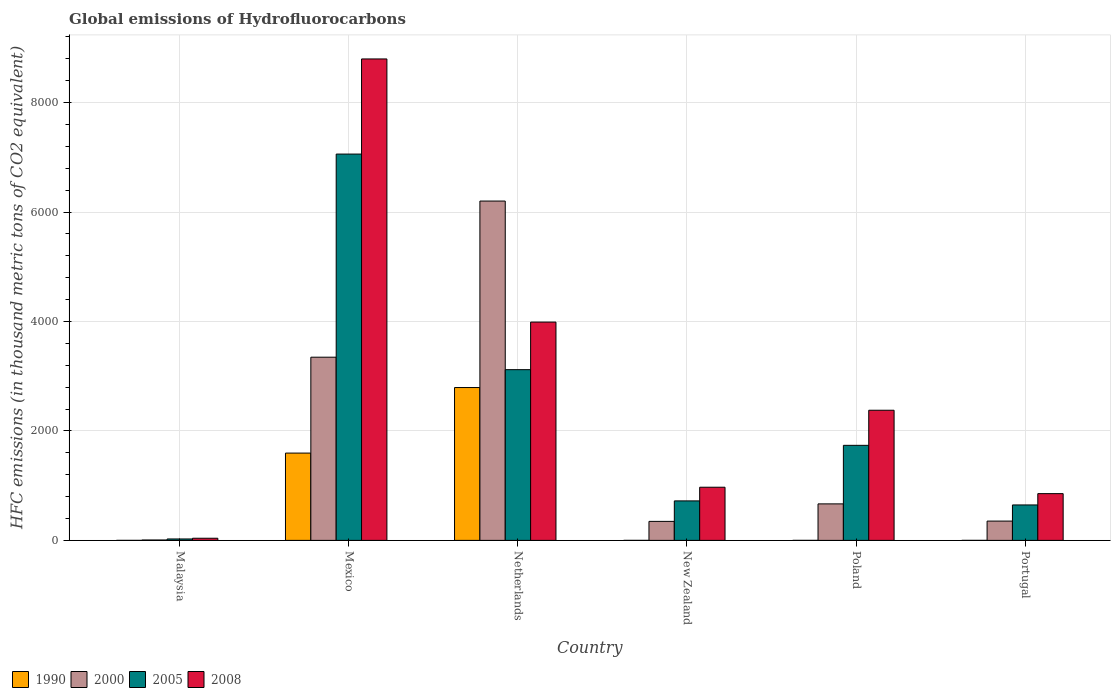Are the number of bars on each tick of the X-axis equal?
Give a very brief answer. Yes. How many bars are there on the 2nd tick from the left?
Make the answer very short. 4. What is the label of the 1st group of bars from the left?
Keep it short and to the point. Malaysia. What is the global emissions of Hydrofluorocarbons in 2008 in Mexico?
Your response must be concise. 8796.9. Across all countries, what is the maximum global emissions of Hydrofluorocarbons in 2008?
Your answer should be compact. 8796.9. Across all countries, what is the minimum global emissions of Hydrofluorocarbons in 2005?
Provide a short and direct response. 26.1. In which country was the global emissions of Hydrofluorocarbons in 1990 maximum?
Make the answer very short. Netherlands. In which country was the global emissions of Hydrofluorocarbons in 2000 minimum?
Provide a short and direct response. Malaysia. What is the total global emissions of Hydrofluorocarbons in 1990 in the graph?
Provide a short and direct response. 4388.8. What is the difference between the global emissions of Hydrofluorocarbons in 2000 in Malaysia and that in Mexico?
Offer a terse response. -3340.4. What is the difference between the global emissions of Hydrofluorocarbons in 2005 in New Zealand and the global emissions of Hydrofluorocarbons in 2008 in Malaysia?
Provide a succinct answer. 682.5. What is the average global emissions of Hydrofluorocarbons in 2000 per country?
Make the answer very short. 1820.3. What is the difference between the global emissions of Hydrofluorocarbons of/in 2008 and global emissions of Hydrofluorocarbons of/in 2000 in Mexico?
Ensure brevity in your answer.  5449.6. In how many countries, is the global emissions of Hydrofluorocarbons in 2005 greater than 400 thousand metric tons?
Your response must be concise. 5. What is the ratio of the global emissions of Hydrofluorocarbons in 2000 in Mexico to that in New Zealand?
Your answer should be compact. 9.64. What is the difference between the highest and the second highest global emissions of Hydrofluorocarbons in 2000?
Offer a terse response. 2853.1. What is the difference between the highest and the lowest global emissions of Hydrofluorocarbons in 1990?
Your answer should be very brief. 2792.8. In how many countries, is the global emissions of Hydrofluorocarbons in 2005 greater than the average global emissions of Hydrofluorocarbons in 2005 taken over all countries?
Your answer should be compact. 2. Is the sum of the global emissions of Hydrofluorocarbons in 1990 in New Zealand and Poland greater than the maximum global emissions of Hydrofluorocarbons in 2005 across all countries?
Provide a short and direct response. No. Is it the case that in every country, the sum of the global emissions of Hydrofluorocarbons in 2008 and global emissions of Hydrofluorocarbons in 2000 is greater than the sum of global emissions of Hydrofluorocarbons in 1990 and global emissions of Hydrofluorocarbons in 2005?
Your answer should be very brief. No. What does the 2nd bar from the left in New Zealand represents?
Your response must be concise. 2000. What does the 4th bar from the right in Malaysia represents?
Offer a terse response. 1990. How many bars are there?
Provide a succinct answer. 24. Are all the bars in the graph horizontal?
Give a very brief answer. No. How many countries are there in the graph?
Offer a terse response. 6. Are the values on the major ticks of Y-axis written in scientific E-notation?
Ensure brevity in your answer.  No. Where does the legend appear in the graph?
Ensure brevity in your answer.  Bottom left. What is the title of the graph?
Offer a terse response. Global emissions of Hydrofluorocarbons. Does "1968" appear as one of the legend labels in the graph?
Provide a short and direct response. No. What is the label or title of the Y-axis?
Make the answer very short. HFC emissions (in thousand metric tons of CO2 equivalent). What is the HFC emissions (in thousand metric tons of CO2 equivalent) in 2000 in Malaysia?
Offer a very short reply. 6.9. What is the HFC emissions (in thousand metric tons of CO2 equivalent) of 2005 in Malaysia?
Your response must be concise. 26.1. What is the HFC emissions (in thousand metric tons of CO2 equivalent) in 2008 in Malaysia?
Provide a short and direct response. 39.2. What is the HFC emissions (in thousand metric tons of CO2 equivalent) in 1990 in Mexico?
Your answer should be very brief. 1595.3. What is the HFC emissions (in thousand metric tons of CO2 equivalent) of 2000 in Mexico?
Your answer should be compact. 3347.3. What is the HFC emissions (in thousand metric tons of CO2 equivalent) of 2005 in Mexico?
Give a very brief answer. 7058.9. What is the HFC emissions (in thousand metric tons of CO2 equivalent) of 2008 in Mexico?
Your answer should be very brief. 8796.9. What is the HFC emissions (in thousand metric tons of CO2 equivalent) of 1990 in Netherlands?
Give a very brief answer. 2792.9. What is the HFC emissions (in thousand metric tons of CO2 equivalent) of 2000 in Netherlands?
Make the answer very short. 6200.4. What is the HFC emissions (in thousand metric tons of CO2 equivalent) in 2005 in Netherlands?
Offer a very short reply. 3119.5. What is the HFC emissions (in thousand metric tons of CO2 equivalent) in 2008 in Netherlands?
Your answer should be compact. 3988.8. What is the HFC emissions (in thousand metric tons of CO2 equivalent) of 2000 in New Zealand?
Keep it short and to the point. 347.3. What is the HFC emissions (in thousand metric tons of CO2 equivalent) in 2005 in New Zealand?
Offer a very short reply. 721.7. What is the HFC emissions (in thousand metric tons of CO2 equivalent) in 2008 in New Zealand?
Your response must be concise. 971.4. What is the HFC emissions (in thousand metric tons of CO2 equivalent) in 1990 in Poland?
Offer a terse response. 0.1. What is the HFC emissions (in thousand metric tons of CO2 equivalent) of 2000 in Poland?
Offer a terse response. 667.2. What is the HFC emissions (in thousand metric tons of CO2 equivalent) in 2005 in Poland?
Ensure brevity in your answer.  1736.7. What is the HFC emissions (in thousand metric tons of CO2 equivalent) in 2008 in Poland?
Ensure brevity in your answer.  2378. What is the HFC emissions (in thousand metric tons of CO2 equivalent) in 2000 in Portugal?
Provide a short and direct response. 352.7. What is the HFC emissions (in thousand metric tons of CO2 equivalent) in 2005 in Portugal?
Give a very brief answer. 647.7. What is the HFC emissions (in thousand metric tons of CO2 equivalent) of 2008 in Portugal?
Make the answer very short. 854.4. Across all countries, what is the maximum HFC emissions (in thousand metric tons of CO2 equivalent) of 1990?
Provide a succinct answer. 2792.9. Across all countries, what is the maximum HFC emissions (in thousand metric tons of CO2 equivalent) of 2000?
Your answer should be compact. 6200.4. Across all countries, what is the maximum HFC emissions (in thousand metric tons of CO2 equivalent) of 2005?
Your answer should be compact. 7058.9. Across all countries, what is the maximum HFC emissions (in thousand metric tons of CO2 equivalent) in 2008?
Your answer should be compact. 8796.9. Across all countries, what is the minimum HFC emissions (in thousand metric tons of CO2 equivalent) of 1990?
Give a very brief answer. 0.1. Across all countries, what is the minimum HFC emissions (in thousand metric tons of CO2 equivalent) of 2005?
Your response must be concise. 26.1. Across all countries, what is the minimum HFC emissions (in thousand metric tons of CO2 equivalent) in 2008?
Your response must be concise. 39.2. What is the total HFC emissions (in thousand metric tons of CO2 equivalent) in 1990 in the graph?
Ensure brevity in your answer.  4388.8. What is the total HFC emissions (in thousand metric tons of CO2 equivalent) of 2000 in the graph?
Your answer should be very brief. 1.09e+04. What is the total HFC emissions (in thousand metric tons of CO2 equivalent) in 2005 in the graph?
Offer a terse response. 1.33e+04. What is the total HFC emissions (in thousand metric tons of CO2 equivalent) in 2008 in the graph?
Keep it short and to the point. 1.70e+04. What is the difference between the HFC emissions (in thousand metric tons of CO2 equivalent) in 1990 in Malaysia and that in Mexico?
Your response must be concise. -1595.2. What is the difference between the HFC emissions (in thousand metric tons of CO2 equivalent) in 2000 in Malaysia and that in Mexico?
Provide a succinct answer. -3340.4. What is the difference between the HFC emissions (in thousand metric tons of CO2 equivalent) in 2005 in Malaysia and that in Mexico?
Make the answer very short. -7032.8. What is the difference between the HFC emissions (in thousand metric tons of CO2 equivalent) in 2008 in Malaysia and that in Mexico?
Make the answer very short. -8757.7. What is the difference between the HFC emissions (in thousand metric tons of CO2 equivalent) of 1990 in Malaysia and that in Netherlands?
Provide a succinct answer. -2792.8. What is the difference between the HFC emissions (in thousand metric tons of CO2 equivalent) of 2000 in Malaysia and that in Netherlands?
Provide a short and direct response. -6193.5. What is the difference between the HFC emissions (in thousand metric tons of CO2 equivalent) of 2005 in Malaysia and that in Netherlands?
Give a very brief answer. -3093.4. What is the difference between the HFC emissions (in thousand metric tons of CO2 equivalent) of 2008 in Malaysia and that in Netherlands?
Give a very brief answer. -3949.6. What is the difference between the HFC emissions (in thousand metric tons of CO2 equivalent) of 2000 in Malaysia and that in New Zealand?
Ensure brevity in your answer.  -340.4. What is the difference between the HFC emissions (in thousand metric tons of CO2 equivalent) in 2005 in Malaysia and that in New Zealand?
Ensure brevity in your answer.  -695.6. What is the difference between the HFC emissions (in thousand metric tons of CO2 equivalent) in 2008 in Malaysia and that in New Zealand?
Provide a short and direct response. -932.2. What is the difference between the HFC emissions (in thousand metric tons of CO2 equivalent) of 1990 in Malaysia and that in Poland?
Provide a succinct answer. 0. What is the difference between the HFC emissions (in thousand metric tons of CO2 equivalent) of 2000 in Malaysia and that in Poland?
Make the answer very short. -660.3. What is the difference between the HFC emissions (in thousand metric tons of CO2 equivalent) of 2005 in Malaysia and that in Poland?
Ensure brevity in your answer.  -1710.6. What is the difference between the HFC emissions (in thousand metric tons of CO2 equivalent) in 2008 in Malaysia and that in Poland?
Make the answer very short. -2338.8. What is the difference between the HFC emissions (in thousand metric tons of CO2 equivalent) of 1990 in Malaysia and that in Portugal?
Keep it short and to the point. -0.1. What is the difference between the HFC emissions (in thousand metric tons of CO2 equivalent) of 2000 in Malaysia and that in Portugal?
Offer a terse response. -345.8. What is the difference between the HFC emissions (in thousand metric tons of CO2 equivalent) in 2005 in Malaysia and that in Portugal?
Make the answer very short. -621.6. What is the difference between the HFC emissions (in thousand metric tons of CO2 equivalent) of 2008 in Malaysia and that in Portugal?
Give a very brief answer. -815.2. What is the difference between the HFC emissions (in thousand metric tons of CO2 equivalent) of 1990 in Mexico and that in Netherlands?
Provide a succinct answer. -1197.6. What is the difference between the HFC emissions (in thousand metric tons of CO2 equivalent) of 2000 in Mexico and that in Netherlands?
Provide a succinct answer. -2853.1. What is the difference between the HFC emissions (in thousand metric tons of CO2 equivalent) in 2005 in Mexico and that in Netherlands?
Provide a short and direct response. 3939.4. What is the difference between the HFC emissions (in thousand metric tons of CO2 equivalent) in 2008 in Mexico and that in Netherlands?
Make the answer very short. 4808.1. What is the difference between the HFC emissions (in thousand metric tons of CO2 equivalent) of 1990 in Mexico and that in New Zealand?
Your response must be concise. 1595.1. What is the difference between the HFC emissions (in thousand metric tons of CO2 equivalent) of 2000 in Mexico and that in New Zealand?
Keep it short and to the point. 3000. What is the difference between the HFC emissions (in thousand metric tons of CO2 equivalent) in 2005 in Mexico and that in New Zealand?
Provide a short and direct response. 6337.2. What is the difference between the HFC emissions (in thousand metric tons of CO2 equivalent) in 2008 in Mexico and that in New Zealand?
Provide a short and direct response. 7825.5. What is the difference between the HFC emissions (in thousand metric tons of CO2 equivalent) of 1990 in Mexico and that in Poland?
Offer a terse response. 1595.2. What is the difference between the HFC emissions (in thousand metric tons of CO2 equivalent) of 2000 in Mexico and that in Poland?
Ensure brevity in your answer.  2680.1. What is the difference between the HFC emissions (in thousand metric tons of CO2 equivalent) in 2005 in Mexico and that in Poland?
Your response must be concise. 5322.2. What is the difference between the HFC emissions (in thousand metric tons of CO2 equivalent) in 2008 in Mexico and that in Poland?
Your answer should be compact. 6418.9. What is the difference between the HFC emissions (in thousand metric tons of CO2 equivalent) of 1990 in Mexico and that in Portugal?
Provide a succinct answer. 1595.1. What is the difference between the HFC emissions (in thousand metric tons of CO2 equivalent) in 2000 in Mexico and that in Portugal?
Offer a very short reply. 2994.6. What is the difference between the HFC emissions (in thousand metric tons of CO2 equivalent) in 2005 in Mexico and that in Portugal?
Make the answer very short. 6411.2. What is the difference between the HFC emissions (in thousand metric tons of CO2 equivalent) of 2008 in Mexico and that in Portugal?
Give a very brief answer. 7942.5. What is the difference between the HFC emissions (in thousand metric tons of CO2 equivalent) of 1990 in Netherlands and that in New Zealand?
Your answer should be very brief. 2792.7. What is the difference between the HFC emissions (in thousand metric tons of CO2 equivalent) in 2000 in Netherlands and that in New Zealand?
Offer a very short reply. 5853.1. What is the difference between the HFC emissions (in thousand metric tons of CO2 equivalent) in 2005 in Netherlands and that in New Zealand?
Ensure brevity in your answer.  2397.8. What is the difference between the HFC emissions (in thousand metric tons of CO2 equivalent) in 2008 in Netherlands and that in New Zealand?
Give a very brief answer. 3017.4. What is the difference between the HFC emissions (in thousand metric tons of CO2 equivalent) of 1990 in Netherlands and that in Poland?
Your answer should be very brief. 2792.8. What is the difference between the HFC emissions (in thousand metric tons of CO2 equivalent) of 2000 in Netherlands and that in Poland?
Give a very brief answer. 5533.2. What is the difference between the HFC emissions (in thousand metric tons of CO2 equivalent) of 2005 in Netherlands and that in Poland?
Make the answer very short. 1382.8. What is the difference between the HFC emissions (in thousand metric tons of CO2 equivalent) in 2008 in Netherlands and that in Poland?
Your response must be concise. 1610.8. What is the difference between the HFC emissions (in thousand metric tons of CO2 equivalent) of 1990 in Netherlands and that in Portugal?
Your answer should be compact. 2792.7. What is the difference between the HFC emissions (in thousand metric tons of CO2 equivalent) of 2000 in Netherlands and that in Portugal?
Offer a very short reply. 5847.7. What is the difference between the HFC emissions (in thousand metric tons of CO2 equivalent) of 2005 in Netherlands and that in Portugal?
Offer a very short reply. 2471.8. What is the difference between the HFC emissions (in thousand metric tons of CO2 equivalent) of 2008 in Netherlands and that in Portugal?
Keep it short and to the point. 3134.4. What is the difference between the HFC emissions (in thousand metric tons of CO2 equivalent) of 2000 in New Zealand and that in Poland?
Offer a terse response. -319.9. What is the difference between the HFC emissions (in thousand metric tons of CO2 equivalent) of 2005 in New Zealand and that in Poland?
Offer a very short reply. -1015. What is the difference between the HFC emissions (in thousand metric tons of CO2 equivalent) in 2008 in New Zealand and that in Poland?
Offer a very short reply. -1406.6. What is the difference between the HFC emissions (in thousand metric tons of CO2 equivalent) of 1990 in New Zealand and that in Portugal?
Your answer should be very brief. 0. What is the difference between the HFC emissions (in thousand metric tons of CO2 equivalent) in 2008 in New Zealand and that in Portugal?
Your response must be concise. 117. What is the difference between the HFC emissions (in thousand metric tons of CO2 equivalent) of 1990 in Poland and that in Portugal?
Provide a short and direct response. -0.1. What is the difference between the HFC emissions (in thousand metric tons of CO2 equivalent) in 2000 in Poland and that in Portugal?
Offer a terse response. 314.5. What is the difference between the HFC emissions (in thousand metric tons of CO2 equivalent) in 2005 in Poland and that in Portugal?
Offer a very short reply. 1089. What is the difference between the HFC emissions (in thousand metric tons of CO2 equivalent) in 2008 in Poland and that in Portugal?
Provide a succinct answer. 1523.6. What is the difference between the HFC emissions (in thousand metric tons of CO2 equivalent) of 1990 in Malaysia and the HFC emissions (in thousand metric tons of CO2 equivalent) of 2000 in Mexico?
Keep it short and to the point. -3347.2. What is the difference between the HFC emissions (in thousand metric tons of CO2 equivalent) of 1990 in Malaysia and the HFC emissions (in thousand metric tons of CO2 equivalent) of 2005 in Mexico?
Your response must be concise. -7058.8. What is the difference between the HFC emissions (in thousand metric tons of CO2 equivalent) in 1990 in Malaysia and the HFC emissions (in thousand metric tons of CO2 equivalent) in 2008 in Mexico?
Offer a very short reply. -8796.8. What is the difference between the HFC emissions (in thousand metric tons of CO2 equivalent) in 2000 in Malaysia and the HFC emissions (in thousand metric tons of CO2 equivalent) in 2005 in Mexico?
Ensure brevity in your answer.  -7052. What is the difference between the HFC emissions (in thousand metric tons of CO2 equivalent) of 2000 in Malaysia and the HFC emissions (in thousand metric tons of CO2 equivalent) of 2008 in Mexico?
Offer a very short reply. -8790. What is the difference between the HFC emissions (in thousand metric tons of CO2 equivalent) of 2005 in Malaysia and the HFC emissions (in thousand metric tons of CO2 equivalent) of 2008 in Mexico?
Make the answer very short. -8770.8. What is the difference between the HFC emissions (in thousand metric tons of CO2 equivalent) of 1990 in Malaysia and the HFC emissions (in thousand metric tons of CO2 equivalent) of 2000 in Netherlands?
Provide a short and direct response. -6200.3. What is the difference between the HFC emissions (in thousand metric tons of CO2 equivalent) of 1990 in Malaysia and the HFC emissions (in thousand metric tons of CO2 equivalent) of 2005 in Netherlands?
Ensure brevity in your answer.  -3119.4. What is the difference between the HFC emissions (in thousand metric tons of CO2 equivalent) in 1990 in Malaysia and the HFC emissions (in thousand metric tons of CO2 equivalent) in 2008 in Netherlands?
Ensure brevity in your answer.  -3988.7. What is the difference between the HFC emissions (in thousand metric tons of CO2 equivalent) of 2000 in Malaysia and the HFC emissions (in thousand metric tons of CO2 equivalent) of 2005 in Netherlands?
Your answer should be compact. -3112.6. What is the difference between the HFC emissions (in thousand metric tons of CO2 equivalent) of 2000 in Malaysia and the HFC emissions (in thousand metric tons of CO2 equivalent) of 2008 in Netherlands?
Your answer should be compact. -3981.9. What is the difference between the HFC emissions (in thousand metric tons of CO2 equivalent) in 2005 in Malaysia and the HFC emissions (in thousand metric tons of CO2 equivalent) in 2008 in Netherlands?
Provide a short and direct response. -3962.7. What is the difference between the HFC emissions (in thousand metric tons of CO2 equivalent) in 1990 in Malaysia and the HFC emissions (in thousand metric tons of CO2 equivalent) in 2000 in New Zealand?
Give a very brief answer. -347.2. What is the difference between the HFC emissions (in thousand metric tons of CO2 equivalent) in 1990 in Malaysia and the HFC emissions (in thousand metric tons of CO2 equivalent) in 2005 in New Zealand?
Give a very brief answer. -721.6. What is the difference between the HFC emissions (in thousand metric tons of CO2 equivalent) in 1990 in Malaysia and the HFC emissions (in thousand metric tons of CO2 equivalent) in 2008 in New Zealand?
Keep it short and to the point. -971.3. What is the difference between the HFC emissions (in thousand metric tons of CO2 equivalent) in 2000 in Malaysia and the HFC emissions (in thousand metric tons of CO2 equivalent) in 2005 in New Zealand?
Give a very brief answer. -714.8. What is the difference between the HFC emissions (in thousand metric tons of CO2 equivalent) in 2000 in Malaysia and the HFC emissions (in thousand metric tons of CO2 equivalent) in 2008 in New Zealand?
Provide a short and direct response. -964.5. What is the difference between the HFC emissions (in thousand metric tons of CO2 equivalent) in 2005 in Malaysia and the HFC emissions (in thousand metric tons of CO2 equivalent) in 2008 in New Zealand?
Keep it short and to the point. -945.3. What is the difference between the HFC emissions (in thousand metric tons of CO2 equivalent) in 1990 in Malaysia and the HFC emissions (in thousand metric tons of CO2 equivalent) in 2000 in Poland?
Keep it short and to the point. -667.1. What is the difference between the HFC emissions (in thousand metric tons of CO2 equivalent) in 1990 in Malaysia and the HFC emissions (in thousand metric tons of CO2 equivalent) in 2005 in Poland?
Provide a succinct answer. -1736.6. What is the difference between the HFC emissions (in thousand metric tons of CO2 equivalent) of 1990 in Malaysia and the HFC emissions (in thousand metric tons of CO2 equivalent) of 2008 in Poland?
Your answer should be very brief. -2377.9. What is the difference between the HFC emissions (in thousand metric tons of CO2 equivalent) in 2000 in Malaysia and the HFC emissions (in thousand metric tons of CO2 equivalent) in 2005 in Poland?
Ensure brevity in your answer.  -1729.8. What is the difference between the HFC emissions (in thousand metric tons of CO2 equivalent) in 2000 in Malaysia and the HFC emissions (in thousand metric tons of CO2 equivalent) in 2008 in Poland?
Your answer should be very brief. -2371.1. What is the difference between the HFC emissions (in thousand metric tons of CO2 equivalent) of 2005 in Malaysia and the HFC emissions (in thousand metric tons of CO2 equivalent) of 2008 in Poland?
Ensure brevity in your answer.  -2351.9. What is the difference between the HFC emissions (in thousand metric tons of CO2 equivalent) in 1990 in Malaysia and the HFC emissions (in thousand metric tons of CO2 equivalent) in 2000 in Portugal?
Ensure brevity in your answer.  -352.6. What is the difference between the HFC emissions (in thousand metric tons of CO2 equivalent) in 1990 in Malaysia and the HFC emissions (in thousand metric tons of CO2 equivalent) in 2005 in Portugal?
Offer a terse response. -647.6. What is the difference between the HFC emissions (in thousand metric tons of CO2 equivalent) of 1990 in Malaysia and the HFC emissions (in thousand metric tons of CO2 equivalent) of 2008 in Portugal?
Provide a succinct answer. -854.3. What is the difference between the HFC emissions (in thousand metric tons of CO2 equivalent) of 2000 in Malaysia and the HFC emissions (in thousand metric tons of CO2 equivalent) of 2005 in Portugal?
Give a very brief answer. -640.8. What is the difference between the HFC emissions (in thousand metric tons of CO2 equivalent) of 2000 in Malaysia and the HFC emissions (in thousand metric tons of CO2 equivalent) of 2008 in Portugal?
Give a very brief answer. -847.5. What is the difference between the HFC emissions (in thousand metric tons of CO2 equivalent) in 2005 in Malaysia and the HFC emissions (in thousand metric tons of CO2 equivalent) in 2008 in Portugal?
Give a very brief answer. -828.3. What is the difference between the HFC emissions (in thousand metric tons of CO2 equivalent) in 1990 in Mexico and the HFC emissions (in thousand metric tons of CO2 equivalent) in 2000 in Netherlands?
Your answer should be compact. -4605.1. What is the difference between the HFC emissions (in thousand metric tons of CO2 equivalent) in 1990 in Mexico and the HFC emissions (in thousand metric tons of CO2 equivalent) in 2005 in Netherlands?
Give a very brief answer. -1524.2. What is the difference between the HFC emissions (in thousand metric tons of CO2 equivalent) in 1990 in Mexico and the HFC emissions (in thousand metric tons of CO2 equivalent) in 2008 in Netherlands?
Your answer should be compact. -2393.5. What is the difference between the HFC emissions (in thousand metric tons of CO2 equivalent) in 2000 in Mexico and the HFC emissions (in thousand metric tons of CO2 equivalent) in 2005 in Netherlands?
Your answer should be compact. 227.8. What is the difference between the HFC emissions (in thousand metric tons of CO2 equivalent) of 2000 in Mexico and the HFC emissions (in thousand metric tons of CO2 equivalent) of 2008 in Netherlands?
Make the answer very short. -641.5. What is the difference between the HFC emissions (in thousand metric tons of CO2 equivalent) in 2005 in Mexico and the HFC emissions (in thousand metric tons of CO2 equivalent) in 2008 in Netherlands?
Your answer should be very brief. 3070.1. What is the difference between the HFC emissions (in thousand metric tons of CO2 equivalent) in 1990 in Mexico and the HFC emissions (in thousand metric tons of CO2 equivalent) in 2000 in New Zealand?
Your answer should be compact. 1248. What is the difference between the HFC emissions (in thousand metric tons of CO2 equivalent) in 1990 in Mexico and the HFC emissions (in thousand metric tons of CO2 equivalent) in 2005 in New Zealand?
Keep it short and to the point. 873.6. What is the difference between the HFC emissions (in thousand metric tons of CO2 equivalent) of 1990 in Mexico and the HFC emissions (in thousand metric tons of CO2 equivalent) of 2008 in New Zealand?
Your response must be concise. 623.9. What is the difference between the HFC emissions (in thousand metric tons of CO2 equivalent) in 2000 in Mexico and the HFC emissions (in thousand metric tons of CO2 equivalent) in 2005 in New Zealand?
Provide a succinct answer. 2625.6. What is the difference between the HFC emissions (in thousand metric tons of CO2 equivalent) of 2000 in Mexico and the HFC emissions (in thousand metric tons of CO2 equivalent) of 2008 in New Zealand?
Provide a succinct answer. 2375.9. What is the difference between the HFC emissions (in thousand metric tons of CO2 equivalent) of 2005 in Mexico and the HFC emissions (in thousand metric tons of CO2 equivalent) of 2008 in New Zealand?
Give a very brief answer. 6087.5. What is the difference between the HFC emissions (in thousand metric tons of CO2 equivalent) in 1990 in Mexico and the HFC emissions (in thousand metric tons of CO2 equivalent) in 2000 in Poland?
Your answer should be compact. 928.1. What is the difference between the HFC emissions (in thousand metric tons of CO2 equivalent) of 1990 in Mexico and the HFC emissions (in thousand metric tons of CO2 equivalent) of 2005 in Poland?
Make the answer very short. -141.4. What is the difference between the HFC emissions (in thousand metric tons of CO2 equivalent) of 1990 in Mexico and the HFC emissions (in thousand metric tons of CO2 equivalent) of 2008 in Poland?
Your answer should be compact. -782.7. What is the difference between the HFC emissions (in thousand metric tons of CO2 equivalent) in 2000 in Mexico and the HFC emissions (in thousand metric tons of CO2 equivalent) in 2005 in Poland?
Your answer should be very brief. 1610.6. What is the difference between the HFC emissions (in thousand metric tons of CO2 equivalent) in 2000 in Mexico and the HFC emissions (in thousand metric tons of CO2 equivalent) in 2008 in Poland?
Your answer should be very brief. 969.3. What is the difference between the HFC emissions (in thousand metric tons of CO2 equivalent) in 2005 in Mexico and the HFC emissions (in thousand metric tons of CO2 equivalent) in 2008 in Poland?
Make the answer very short. 4680.9. What is the difference between the HFC emissions (in thousand metric tons of CO2 equivalent) of 1990 in Mexico and the HFC emissions (in thousand metric tons of CO2 equivalent) of 2000 in Portugal?
Make the answer very short. 1242.6. What is the difference between the HFC emissions (in thousand metric tons of CO2 equivalent) in 1990 in Mexico and the HFC emissions (in thousand metric tons of CO2 equivalent) in 2005 in Portugal?
Offer a terse response. 947.6. What is the difference between the HFC emissions (in thousand metric tons of CO2 equivalent) of 1990 in Mexico and the HFC emissions (in thousand metric tons of CO2 equivalent) of 2008 in Portugal?
Make the answer very short. 740.9. What is the difference between the HFC emissions (in thousand metric tons of CO2 equivalent) of 2000 in Mexico and the HFC emissions (in thousand metric tons of CO2 equivalent) of 2005 in Portugal?
Provide a short and direct response. 2699.6. What is the difference between the HFC emissions (in thousand metric tons of CO2 equivalent) in 2000 in Mexico and the HFC emissions (in thousand metric tons of CO2 equivalent) in 2008 in Portugal?
Offer a very short reply. 2492.9. What is the difference between the HFC emissions (in thousand metric tons of CO2 equivalent) of 2005 in Mexico and the HFC emissions (in thousand metric tons of CO2 equivalent) of 2008 in Portugal?
Your response must be concise. 6204.5. What is the difference between the HFC emissions (in thousand metric tons of CO2 equivalent) of 1990 in Netherlands and the HFC emissions (in thousand metric tons of CO2 equivalent) of 2000 in New Zealand?
Your answer should be compact. 2445.6. What is the difference between the HFC emissions (in thousand metric tons of CO2 equivalent) in 1990 in Netherlands and the HFC emissions (in thousand metric tons of CO2 equivalent) in 2005 in New Zealand?
Give a very brief answer. 2071.2. What is the difference between the HFC emissions (in thousand metric tons of CO2 equivalent) in 1990 in Netherlands and the HFC emissions (in thousand metric tons of CO2 equivalent) in 2008 in New Zealand?
Offer a very short reply. 1821.5. What is the difference between the HFC emissions (in thousand metric tons of CO2 equivalent) of 2000 in Netherlands and the HFC emissions (in thousand metric tons of CO2 equivalent) of 2005 in New Zealand?
Your response must be concise. 5478.7. What is the difference between the HFC emissions (in thousand metric tons of CO2 equivalent) of 2000 in Netherlands and the HFC emissions (in thousand metric tons of CO2 equivalent) of 2008 in New Zealand?
Give a very brief answer. 5229. What is the difference between the HFC emissions (in thousand metric tons of CO2 equivalent) of 2005 in Netherlands and the HFC emissions (in thousand metric tons of CO2 equivalent) of 2008 in New Zealand?
Offer a terse response. 2148.1. What is the difference between the HFC emissions (in thousand metric tons of CO2 equivalent) of 1990 in Netherlands and the HFC emissions (in thousand metric tons of CO2 equivalent) of 2000 in Poland?
Your response must be concise. 2125.7. What is the difference between the HFC emissions (in thousand metric tons of CO2 equivalent) in 1990 in Netherlands and the HFC emissions (in thousand metric tons of CO2 equivalent) in 2005 in Poland?
Ensure brevity in your answer.  1056.2. What is the difference between the HFC emissions (in thousand metric tons of CO2 equivalent) of 1990 in Netherlands and the HFC emissions (in thousand metric tons of CO2 equivalent) of 2008 in Poland?
Provide a short and direct response. 414.9. What is the difference between the HFC emissions (in thousand metric tons of CO2 equivalent) in 2000 in Netherlands and the HFC emissions (in thousand metric tons of CO2 equivalent) in 2005 in Poland?
Your answer should be very brief. 4463.7. What is the difference between the HFC emissions (in thousand metric tons of CO2 equivalent) in 2000 in Netherlands and the HFC emissions (in thousand metric tons of CO2 equivalent) in 2008 in Poland?
Provide a succinct answer. 3822.4. What is the difference between the HFC emissions (in thousand metric tons of CO2 equivalent) in 2005 in Netherlands and the HFC emissions (in thousand metric tons of CO2 equivalent) in 2008 in Poland?
Make the answer very short. 741.5. What is the difference between the HFC emissions (in thousand metric tons of CO2 equivalent) of 1990 in Netherlands and the HFC emissions (in thousand metric tons of CO2 equivalent) of 2000 in Portugal?
Give a very brief answer. 2440.2. What is the difference between the HFC emissions (in thousand metric tons of CO2 equivalent) of 1990 in Netherlands and the HFC emissions (in thousand metric tons of CO2 equivalent) of 2005 in Portugal?
Give a very brief answer. 2145.2. What is the difference between the HFC emissions (in thousand metric tons of CO2 equivalent) of 1990 in Netherlands and the HFC emissions (in thousand metric tons of CO2 equivalent) of 2008 in Portugal?
Ensure brevity in your answer.  1938.5. What is the difference between the HFC emissions (in thousand metric tons of CO2 equivalent) of 2000 in Netherlands and the HFC emissions (in thousand metric tons of CO2 equivalent) of 2005 in Portugal?
Provide a short and direct response. 5552.7. What is the difference between the HFC emissions (in thousand metric tons of CO2 equivalent) in 2000 in Netherlands and the HFC emissions (in thousand metric tons of CO2 equivalent) in 2008 in Portugal?
Ensure brevity in your answer.  5346. What is the difference between the HFC emissions (in thousand metric tons of CO2 equivalent) of 2005 in Netherlands and the HFC emissions (in thousand metric tons of CO2 equivalent) of 2008 in Portugal?
Offer a terse response. 2265.1. What is the difference between the HFC emissions (in thousand metric tons of CO2 equivalent) in 1990 in New Zealand and the HFC emissions (in thousand metric tons of CO2 equivalent) in 2000 in Poland?
Provide a short and direct response. -667. What is the difference between the HFC emissions (in thousand metric tons of CO2 equivalent) of 1990 in New Zealand and the HFC emissions (in thousand metric tons of CO2 equivalent) of 2005 in Poland?
Give a very brief answer. -1736.5. What is the difference between the HFC emissions (in thousand metric tons of CO2 equivalent) of 1990 in New Zealand and the HFC emissions (in thousand metric tons of CO2 equivalent) of 2008 in Poland?
Ensure brevity in your answer.  -2377.8. What is the difference between the HFC emissions (in thousand metric tons of CO2 equivalent) in 2000 in New Zealand and the HFC emissions (in thousand metric tons of CO2 equivalent) in 2005 in Poland?
Your answer should be very brief. -1389.4. What is the difference between the HFC emissions (in thousand metric tons of CO2 equivalent) of 2000 in New Zealand and the HFC emissions (in thousand metric tons of CO2 equivalent) of 2008 in Poland?
Your response must be concise. -2030.7. What is the difference between the HFC emissions (in thousand metric tons of CO2 equivalent) in 2005 in New Zealand and the HFC emissions (in thousand metric tons of CO2 equivalent) in 2008 in Poland?
Your response must be concise. -1656.3. What is the difference between the HFC emissions (in thousand metric tons of CO2 equivalent) of 1990 in New Zealand and the HFC emissions (in thousand metric tons of CO2 equivalent) of 2000 in Portugal?
Your answer should be compact. -352.5. What is the difference between the HFC emissions (in thousand metric tons of CO2 equivalent) of 1990 in New Zealand and the HFC emissions (in thousand metric tons of CO2 equivalent) of 2005 in Portugal?
Offer a very short reply. -647.5. What is the difference between the HFC emissions (in thousand metric tons of CO2 equivalent) of 1990 in New Zealand and the HFC emissions (in thousand metric tons of CO2 equivalent) of 2008 in Portugal?
Make the answer very short. -854.2. What is the difference between the HFC emissions (in thousand metric tons of CO2 equivalent) in 2000 in New Zealand and the HFC emissions (in thousand metric tons of CO2 equivalent) in 2005 in Portugal?
Your answer should be very brief. -300.4. What is the difference between the HFC emissions (in thousand metric tons of CO2 equivalent) in 2000 in New Zealand and the HFC emissions (in thousand metric tons of CO2 equivalent) in 2008 in Portugal?
Keep it short and to the point. -507.1. What is the difference between the HFC emissions (in thousand metric tons of CO2 equivalent) of 2005 in New Zealand and the HFC emissions (in thousand metric tons of CO2 equivalent) of 2008 in Portugal?
Give a very brief answer. -132.7. What is the difference between the HFC emissions (in thousand metric tons of CO2 equivalent) of 1990 in Poland and the HFC emissions (in thousand metric tons of CO2 equivalent) of 2000 in Portugal?
Offer a very short reply. -352.6. What is the difference between the HFC emissions (in thousand metric tons of CO2 equivalent) in 1990 in Poland and the HFC emissions (in thousand metric tons of CO2 equivalent) in 2005 in Portugal?
Provide a short and direct response. -647.6. What is the difference between the HFC emissions (in thousand metric tons of CO2 equivalent) of 1990 in Poland and the HFC emissions (in thousand metric tons of CO2 equivalent) of 2008 in Portugal?
Your response must be concise. -854.3. What is the difference between the HFC emissions (in thousand metric tons of CO2 equivalent) in 2000 in Poland and the HFC emissions (in thousand metric tons of CO2 equivalent) in 2005 in Portugal?
Provide a short and direct response. 19.5. What is the difference between the HFC emissions (in thousand metric tons of CO2 equivalent) of 2000 in Poland and the HFC emissions (in thousand metric tons of CO2 equivalent) of 2008 in Portugal?
Offer a very short reply. -187.2. What is the difference between the HFC emissions (in thousand metric tons of CO2 equivalent) of 2005 in Poland and the HFC emissions (in thousand metric tons of CO2 equivalent) of 2008 in Portugal?
Make the answer very short. 882.3. What is the average HFC emissions (in thousand metric tons of CO2 equivalent) of 1990 per country?
Provide a succinct answer. 731.47. What is the average HFC emissions (in thousand metric tons of CO2 equivalent) of 2000 per country?
Provide a succinct answer. 1820.3. What is the average HFC emissions (in thousand metric tons of CO2 equivalent) of 2005 per country?
Offer a very short reply. 2218.43. What is the average HFC emissions (in thousand metric tons of CO2 equivalent) of 2008 per country?
Your response must be concise. 2838.12. What is the difference between the HFC emissions (in thousand metric tons of CO2 equivalent) of 1990 and HFC emissions (in thousand metric tons of CO2 equivalent) of 2005 in Malaysia?
Offer a terse response. -26. What is the difference between the HFC emissions (in thousand metric tons of CO2 equivalent) in 1990 and HFC emissions (in thousand metric tons of CO2 equivalent) in 2008 in Malaysia?
Your answer should be compact. -39.1. What is the difference between the HFC emissions (in thousand metric tons of CO2 equivalent) in 2000 and HFC emissions (in thousand metric tons of CO2 equivalent) in 2005 in Malaysia?
Offer a terse response. -19.2. What is the difference between the HFC emissions (in thousand metric tons of CO2 equivalent) of 2000 and HFC emissions (in thousand metric tons of CO2 equivalent) of 2008 in Malaysia?
Ensure brevity in your answer.  -32.3. What is the difference between the HFC emissions (in thousand metric tons of CO2 equivalent) in 1990 and HFC emissions (in thousand metric tons of CO2 equivalent) in 2000 in Mexico?
Your answer should be very brief. -1752. What is the difference between the HFC emissions (in thousand metric tons of CO2 equivalent) in 1990 and HFC emissions (in thousand metric tons of CO2 equivalent) in 2005 in Mexico?
Your answer should be compact. -5463.6. What is the difference between the HFC emissions (in thousand metric tons of CO2 equivalent) in 1990 and HFC emissions (in thousand metric tons of CO2 equivalent) in 2008 in Mexico?
Provide a succinct answer. -7201.6. What is the difference between the HFC emissions (in thousand metric tons of CO2 equivalent) in 2000 and HFC emissions (in thousand metric tons of CO2 equivalent) in 2005 in Mexico?
Ensure brevity in your answer.  -3711.6. What is the difference between the HFC emissions (in thousand metric tons of CO2 equivalent) in 2000 and HFC emissions (in thousand metric tons of CO2 equivalent) in 2008 in Mexico?
Offer a terse response. -5449.6. What is the difference between the HFC emissions (in thousand metric tons of CO2 equivalent) in 2005 and HFC emissions (in thousand metric tons of CO2 equivalent) in 2008 in Mexico?
Keep it short and to the point. -1738. What is the difference between the HFC emissions (in thousand metric tons of CO2 equivalent) of 1990 and HFC emissions (in thousand metric tons of CO2 equivalent) of 2000 in Netherlands?
Offer a terse response. -3407.5. What is the difference between the HFC emissions (in thousand metric tons of CO2 equivalent) of 1990 and HFC emissions (in thousand metric tons of CO2 equivalent) of 2005 in Netherlands?
Offer a very short reply. -326.6. What is the difference between the HFC emissions (in thousand metric tons of CO2 equivalent) of 1990 and HFC emissions (in thousand metric tons of CO2 equivalent) of 2008 in Netherlands?
Offer a terse response. -1195.9. What is the difference between the HFC emissions (in thousand metric tons of CO2 equivalent) in 2000 and HFC emissions (in thousand metric tons of CO2 equivalent) in 2005 in Netherlands?
Keep it short and to the point. 3080.9. What is the difference between the HFC emissions (in thousand metric tons of CO2 equivalent) in 2000 and HFC emissions (in thousand metric tons of CO2 equivalent) in 2008 in Netherlands?
Give a very brief answer. 2211.6. What is the difference between the HFC emissions (in thousand metric tons of CO2 equivalent) of 2005 and HFC emissions (in thousand metric tons of CO2 equivalent) of 2008 in Netherlands?
Offer a terse response. -869.3. What is the difference between the HFC emissions (in thousand metric tons of CO2 equivalent) of 1990 and HFC emissions (in thousand metric tons of CO2 equivalent) of 2000 in New Zealand?
Make the answer very short. -347.1. What is the difference between the HFC emissions (in thousand metric tons of CO2 equivalent) in 1990 and HFC emissions (in thousand metric tons of CO2 equivalent) in 2005 in New Zealand?
Offer a very short reply. -721.5. What is the difference between the HFC emissions (in thousand metric tons of CO2 equivalent) of 1990 and HFC emissions (in thousand metric tons of CO2 equivalent) of 2008 in New Zealand?
Your answer should be compact. -971.2. What is the difference between the HFC emissions (in thousand metric tons of CO2 equivalent) in 2000 and HFC emissions (in thousand metric tons of CO2 equivalent) in 2005 in New Zealand?
Ensure brevity in your answer.  -374.4. What is the difference between the HFC emissions (in thousand metric tons of CO2 equivalent) of 2000 and HFC emissions (in thousand metric tons of CO2 equivalent) of 2008 in New Zealand?
Keep it short and to the point. -624.1. What is the difference between the HFC emissions (in thousand metric tons of CO2 equivalent) of 2005 and HFC emissions (in thousand metric tons of CO2 equivalent) of 2008 in New Zealand?
Make the answer very short. -249.7. What is the difference between the HFC emissions (in thousand metric tons of CO2 equivalent) in 1990 and HFC emissions (in thousand metric tons of CO2 equivalent) in 2000 in Poland?
Your answer should be compact. -667.1. What is the difference between the HFC emissions (in thousand metric tons of CO2 equivalent) in 1990 and HFC emissions (in thousand metric tons of CO2 equivalent) in 2005 in Poland?
Your answer should be compact. -1736.6. What is the difference between the HFC emissions (in thousand metric tons of CO2 equivalent) of 1990 and HFC emissions (in thousand metric tons of CO2 equivalent) of 2008 in Poland?
Provide a short and direct response. -2377.9. What is the difference between the HFC emissions (in thousand metric tons of CO2 equivalent) in 2000 and HFC emissions (in thousand metric tons of CO2 equivalent) in 2005 in Poland?
Provide a short and direct response. -1069.5. What is the difference between the HFC emissions (in thousand metric tons of CO2 equivalent) of 2000 and HFC emissions (in thousand metric tons of CO2 equivalent) of 2008 in Poland?
Keep it short and to the point. -1710.8. What is the difference between the HFC emissions (in thousand metric tons of CO2 equivalent) in 2005 and HFC emissions (in thousand metric tons of CO2 equivalent) in 2008 in Poland?
Your answer should be compact. -641.3. What is the difference between the HFC emissions (in thousand metric tons of CO2 equivalent) of 1990 and HFC emissions (in thousand metric tons of CO2 equivalent) of 2000 in Portugal?
Give a very brief answer. -352.5. What is the difference between the HFC emissions (in thousand metric tons of CO2 equivalent) in 1990 and HFC emissions (in thousand metric tons of CO2 equivalent) in 2005 in Portugal?
Offer a very short reply. -647.5. What is the difference between the HFC emissions (in thousand metric tons of CO2 equivalent) of 1990 and HFC emissions (in thousand metric tons of CO2 equivalent) of 2008 in Portugal?
Your answer should be compact. -854.2. What is the difference between the HFC emissions (in thousand metric tons of CO2 equivalent) in 2000 and HFC emissions (in thousand metric tons of CO2 equivalent) in 2005 in Portugal?
Offer a very short reply. -295. What is the difference between the HFC emissions (in thousand metric tons of CO2 equivalent) of 2000 and HFC emissions (in thousand metric tons of CO2 equivalent) of 2008 in Portugal?
Provide a succinct answer. -501.7. What is the difference between the HFC emissions (in thousand metric tons of CO2 equivalent) in 2005 and HFC emissions (in thousand metric tons of CO2 equivalent) in 2008 in Portugal?
Your answer should be very brief. -206.7. What is the ratio of the HFC emissions (in thousand metric tons of CO2 equivalent) in 2000 in Malaysia to that in Mexico?
Your answer should be very brief. 0. What is the ratio of the HFC emissions (in thousand metric tons of CO2 equivalent) in 2005 in Malaysia to that in Mexico?
Ensure brevity in your answer.  0. What is the ratio of the HFC emissions (in thousand metric tons of CO2 equivalent) in 2008 in Malaysia to that in Mexico?
Keep it short and to the point. 0. What is the ratio of the HFC emissions (in thousand metric tons of CO2 equivalent) in 1990 in Malaysia to that in Netherlands?
Give a very brief answer. 0. What is the ratio of the HFC emissions (in thousand metric tons of CO2 equivalent) in 2000 in Malaysia to that in Netherlands?
Offer a very short reply. 0. What is the ratio of the HFC emissions (in thousand metric tons of CO2 equivalent) of 2005 in Malaysia to that in Netherlands?
Provide a succinct answer. 0.01. What is the ratio of the HFC emissions (in thousand metric tons of CO2 equivalent) of 2008 in Malaysia to that in Netherlands?
Your answer should be compact. 0.01. What is the ratio of the HFC emissions (in thousand metric tons of CO2 equivalent) of 1990 in Malaysia to that in New Zealand?
Provide a succinct answer. 0.5. What is the ratio of the HFC emissions (in thousand metric tons of CO2 equivalent) in 2000 in Malaysia to that in New Zealand?
Your answer should be compact. 0.02. What is the ratio of the HFC emissions (in thousand metric tons of CO2 equivalent) of 2005 in Malaysia to that in New Zealand?
Keep it short and to the point. 0.04. What is the ratio of the HFC emissions (in thousand metric tons of CO2 equivalent) in 2008 in Malaysia to that in New Zealand?
Provide a succinct answer. 0.04. What is the ratio of the HFC emissions (in thousand metric tons of CO2 equivalent) of 1990 in Malaysia to that in Poland?
Ensure brevity in your answer.  1. What is the ratio of the HFC emissions (in thousand metric tons of CO2 equivalent) of 2000 in Malaysia to that in Poland?
Give a very brief answer. 0.01. What is the ratio of the HFC emissions (in thousand metric tons of CO2 equivalent) in 2005 in Malaysia to that in Poland?
Your response must be concise. 0.01. What is the ratio of the HFC emissions (in thousand metric tons of CO2 equivalent) in 2008 in Malaysia to that in Poland?
Keep it short and to the point. 0.02. What is the ratio of the HFC emissions (in thousand metric tons of CO2 equivalent) of 1990 in Malaysia to that in Portugal?
Offer a terse response. 0.5. What is the ratio of the HFC emissions (in thousand metric tons of CO2 equivalent) of 2000 in Malaysia to that in Portugal?
Provide a short and direct response. 0.02. What is the ratio of the HFC emissions (in thousand metric tons of CO2 equivalent) of 2005 in Malaysia to that in Portugal?
Your response must be concise. 0.04. What is the ratio of the HFC emissions (in thousand metric tons of CO2 equivalent) in 2008 in Malaysia to that in Portugal?
Provide a succinct answer. 0.05. What is the ratio of the HFC emissions (in thousand metric tons of CO2 equivalent) of 1990 in Mexico to that in Netherlands?
Offer a terse response. 0.57. What is the ratio of the HFC emissions (in thousand metric tons of CO2 equivalent) of 2000 in Mexico to that in Netherlands?
Offer a very short reply. 0.54. What is the ratio of the HFC emissions (in thousand metric tons of CO2 equivalent) of 2005 in Mexico to that in Netherlands?
Provide a short and direct response. 2.26. What is the ratio of the HFC emissions (in thousand metric tons of CO2 equivalent) of 2008 in Mexico to that in Netherlands?
Provide a short and direct response. 2.21. What is the ratio of the HFC emissions (in thousand metric tons of CO2 equivalent) of 1990 in Mexico to that in New Zealand?
Offer a very short reply. 7976.5. What is the ratio of the HFC emissions (in thousand metric tons of CO2 equivalent) in 2000 in Mexico to that in New Zealand?
Your answer should be very brief. 9.64. What is the ratio of the HFC emissions (in thousand metric tons of CO2 equivalent) in 2005 in Mexico to that in New Zealand?
Provide a succinct answer. 9.78. What is the ratio of the HFC emissions (in thousand metric tons of CO2 equivalent) in 2008 in Mexico to that in New Zealand?
Keep it short and to the point. 9.06. What is the ratio of the HFC emissions (in thousand metric tons of CO2 equivalent) of 1990 in Mexico to that in Poland?
Provide a short and direct response. 1.60e+04. What is the ratio of the HFC emissions (in thousand metric tons of CO2 equivalent) of 2000 in Mexico to that in Poland?
Provide a succinct answer. 5.02. What is the ratio of the HFC emissions (in thousand metric tons of CO2 equivalent) of 2005 in Mexico to that in Poland?
Provide a succinct answer. 4.06. What is the ratio of the HFC emissions (in thousand metric tons of CO2 equivalent) of 2008 in Mexico to that in Poland?
Make the answer very short. 3.7. What is the ratio of the HFC emissions (in thousand metric tons of CO2 equivalent) of 1990 in Mexico to that in Portugal?
Offer a terse response. 7976.5. What is the ratio of the HFC emissions (in thousand metric tons of CO2 equivalent) of 2000 in Mexico to that in Portugal?
Your answer should be compact. 9.49. What is the ratio of the HFC emissions (in thousand metric tons of CO2 equivalent) in 2005 in Mexico to that in Portugal?
Make the answer very short. 10.9. What is the ratio of the HFC emissions (in thousand metric tons of CO2 equivalent) of 2008 in Mexico to that in Portugal?
Your answer should be compact. 10.3. What is the ratio of the HFC emissions (in thousand metric tons of CO2 equivalent) of 1990 in Netherlands to that in New Zealand?
Your answer should be very brief. 1.40e+04. What is the ratio of the HFC emissions (in thousand metric tons of CO2 equivalent) in 2000 in Netherlands to that in New Zealand?
Provide a succinct answer. 17.85. What is the ratio of the HFC emissions (in thousand metric tons of CO2 equivalent) of 2005 in Netherlands to that in New Zealand?
Your response must be concise. 4.32. What is the ratio of the HFC emissions (in thousand metric tons of CO2 equivalent) in 2008 in Netherlands to that in New Zealand?
Offer a terse response. 4.11. What is the ratio of the HFC emissions (in thousand metric tons of CO2 equivalent) of 1990 in Netherlands to that in Poland?
Ensure brevity in your answer.  2.79e+04. What is the ratio of the HFC emissions (in thousand metric tons of CO2 equivalent) of 2000 in Netherlands to that in Poland?
Your answer should be compact. 9.29. What is the ratio of the HFC emissions (in thousand metric tons of CO2 equivalent) of 2005 in Netherlands to that in Poland?
Ensure brevity in your answer.  1.8. What is the ratio of the HFC emissions (in thousand metric tons of CO2 equivalent) of 2008 in Netherlands to that in Poland?
Make the answer very short. 1.68. What is the ratio of the HFC emissions (in thousand metric tons of CO2 equivalent) in 1990 in Netherlands to that in Portugal?
Ensure brevity in your answer.  1.40e+04. What is the ratio of the HFC emissions (in thousand metric tons of CO2 equivalent) in 2000 in Netherlands to that in Portugal?
Give a very brief answer. 17.58. What is the ratio of the HFC emissions (in thousand metric tons of CO2 equivalent) in 2005 in Netherlands to that in Portugal?
Ensure brevity in your answer.  4.82. What is the ratio of the HFC emissions (in thousand metric tons of CO2 equivalent) in 2008 in Netherlands to that in Portugal?
Keep it short and to the point. 4.67. What is the ratio of the HFC emissions (in thousand metric tons of CO2 equivalent) of 2000 in New Zealand to that in Poland?
Provide a short and direct response. 0.52. What is the ratio of the HFC emissions (in thousand metric tons of CO2 equivalent) of 2005 in New Zealand to that in Poland?
Your answer should be compact. 0.42. What is the ratio of the HFC emissions (in thousand metric tons of CO2 equivalent) in 2008 in New Zealand to that in Poland?
Your answer should be very brief. 0.41. What is the ratio of the HFC emissions (in thousand metric tons of CO2 equivalent) of 2000 in New Zealand to that in Portugal?
Offer a very short reply. 0.98. What is the ratio of the HFC emissions (in thousand metric tons of CO2 equivalent) in 2005 in New Zealand to that in Portugal?
Offer a terse response. 1.11. What is the ratio of the HFC emissions (in thousand metric tons of CO2 equivalent) in 2008 in New Zealand to that in Portugal?
Keep it short and to the point. 1.14. What is the ratio of the HFC emissions (in thousand metric tons of CO2 equivalent) of 1990 in Poland to that in Portugal?
Offer a terse response. 0.5. What is the ratio of the HFC emissions (in thousand metric tons of CO2 equivalent) of 2000 in Poland to that in Portugal?
Keep it short and to the point. 1.89. What is the ratio of the HFC emissions (in thousand metric tons of CO2 equivalent) of 2005 in Poland to that in Portugal?
Provide a succinct answer. 2.68. What is the ratio of the HFC emissions (in thousand metric tons of CO2 equivalent) in 2008 in Poland to that in Portugal?
Your answer should be compact. 2.78. What is the difference between the highest and the second highest HFC emissions (in thousand metric tons of CO2 equivalent) in 1990?
Your answer should be very brief. 1197.6. What is the difference between the highest and the second highest HFC emissions (in thousand metric tons of CO2 equivalent) of 2000?
Keep it short and to the point. 2853.1. What is the difference between the highest and the second highest HFC emissions (in thousand metric tons of CO2 equivalent) of 2005?
Ensure brevity in your answer.  3939.4. What is the difference between the highest and the second highest HFC emissions (in thousand metric tons of CO2 equivalent) in 2008?
Your answer should be very brief. 4808.1. What is the difference between the highest and the lowest HFC emissions (in thousand metric tons of CO2 equivalent) of 1990?
Provide a short and direct response. 2792.8. What is the difference between the highest and the lowest HFC emissions (in thousand metric tons of CO2 equivalent) of 2000?
Your answer should be compact. 6193.5. What is the difference between the highest and the lowest HFC emissions (in thousand metric tons of CO2 equivalent) in 2005?
Keep it short and to the point. 7032.8. What is the difference between the highest and the lowest HFC emissions (in thousand metric tons of CO2 equivalent) in 2008?
Ensure brevity in your answer.  8757.7. 